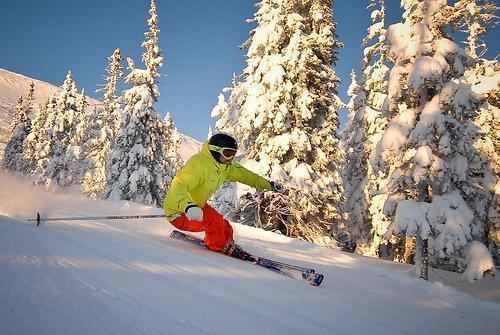How many men are there?
Give a very brief answer. 1. How many skiing sticks are touching snow?
Give a very brief answer. 1. 